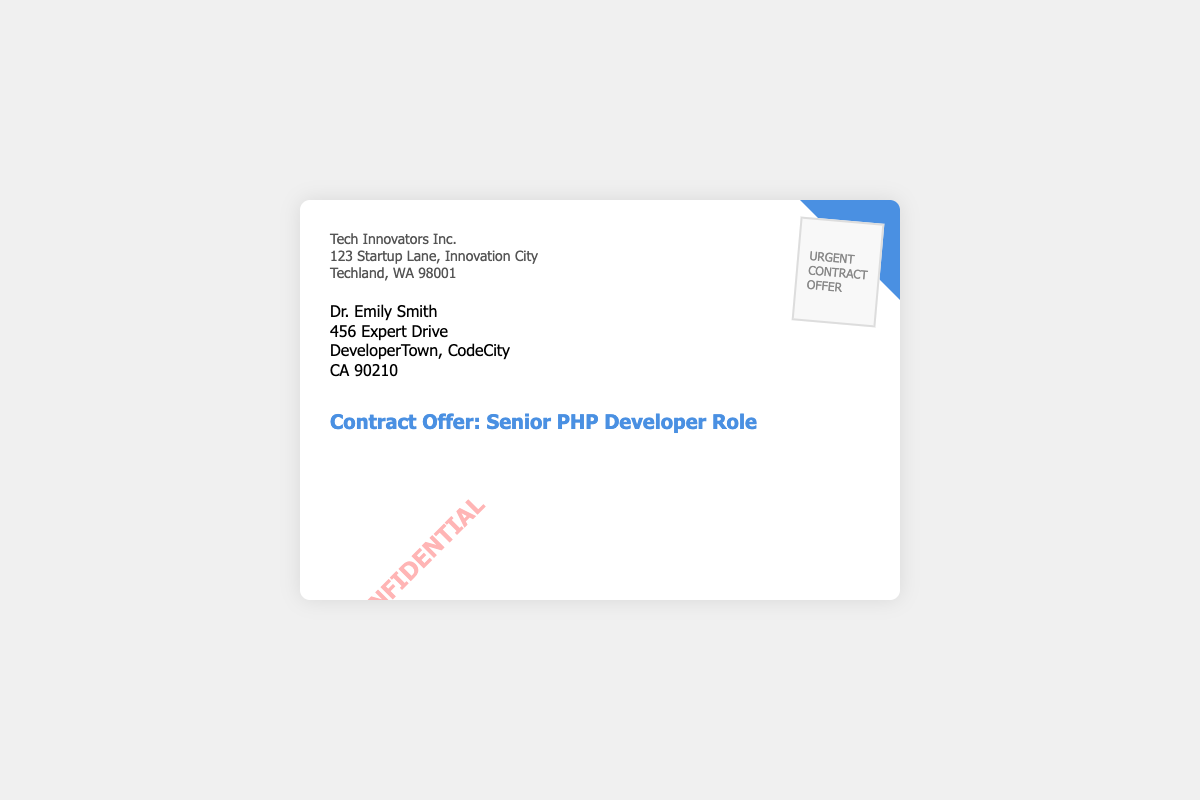What is the name of the company? The company's name is stated at the top of the document.
Answer: Tech Innovators Inc Who is the recipient of the envelope? The recipient's name is provided in the recipient info section.
Answer: Dr. Emily Smith What is the address of the company? The complete address of the company can be found in the company info section.
Answer: 123 Startup Lane, Innovation City, Techland, WA 98001 What role is being offered? The subject line indicates the position being offered.
Answer: Senior PHP Developer Role What stamp is on the envelope? The content of the stamp is prominently displayed on the envelope.
Answer: URGENT, CONTRACT, OFFER How many lines are there in the company info section? The number of lines can be counted in the company info section.
Answer: Three lines What city is the recipient located in? The city of the recipient is specified in the recipient info section.
Answer: DeveloperTown What is the color of the confidential text? The color of the confidential text can be deduced from its display.
Answer: Red What position does the recipient hold? The title or position of the recipient is implied in the context of the envelope.
Answer: Doctor 